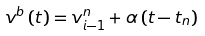Convert formula to latex. <formula><loc_0><loc_0><loc_500><loc_500>v ^ { b } \left ( t \right ) = v ^ { n } _ { i - 1 } + \alpha \left ( t - t _ { n } \right )</formula> 